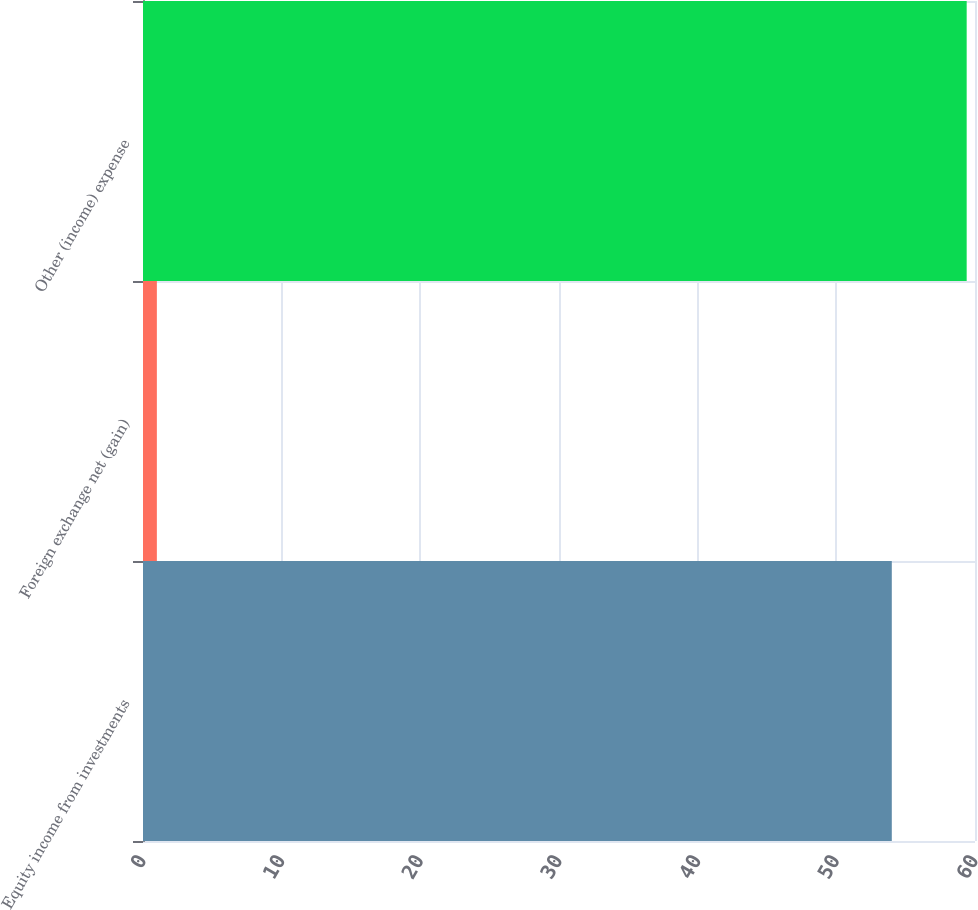Convert chart to OTSL. <chart><loc_0><loc_0><loc_500><loc_500><bar_chart><fcel>Equity income from investments<fcel>Foreign exchange net (gain)<fcel>Other (income) expense<nl><fcel>54<fcel>1<fcel>59.4<nl></chart> 